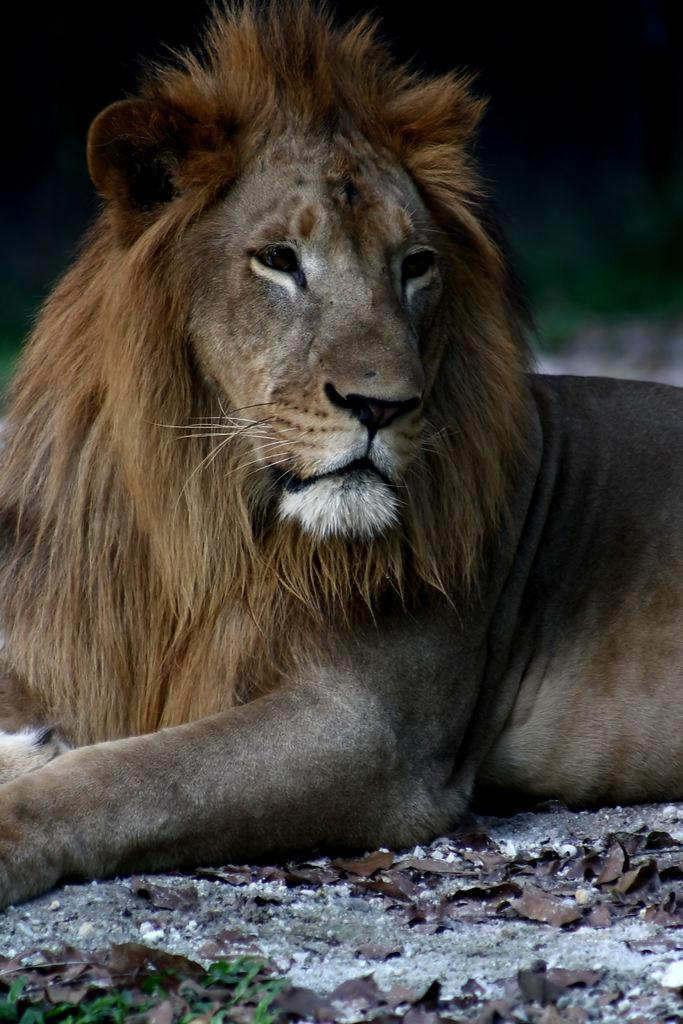What animal is the main subject of the image? There is a lion in the image. What is the position of the lion in the image? The lion is on the ground. Can you describe the background of the image? The background of the image is blurred. What type of guitar can be seen being played by the lion in the image? There is no guitar present in the image, and the lion is not playing any instrument. Can you tell me how many chess pieces are visible on the ground in the image? There are no chess pieces visible in the image; the main subject is a lion on the ground. 